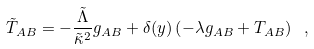<formula> <loc_0><loc_0><loc_500><loc_500>\tilde { T } _ { A B } = - \frac { \tilde { \Lambda } } { \tilde { \kappa } ^ { 2 } } g _ { A B } + \delta ( y ) \left ( - \lambda g _ { A B } + T _ { A B } \right ) \ ,</formula> 